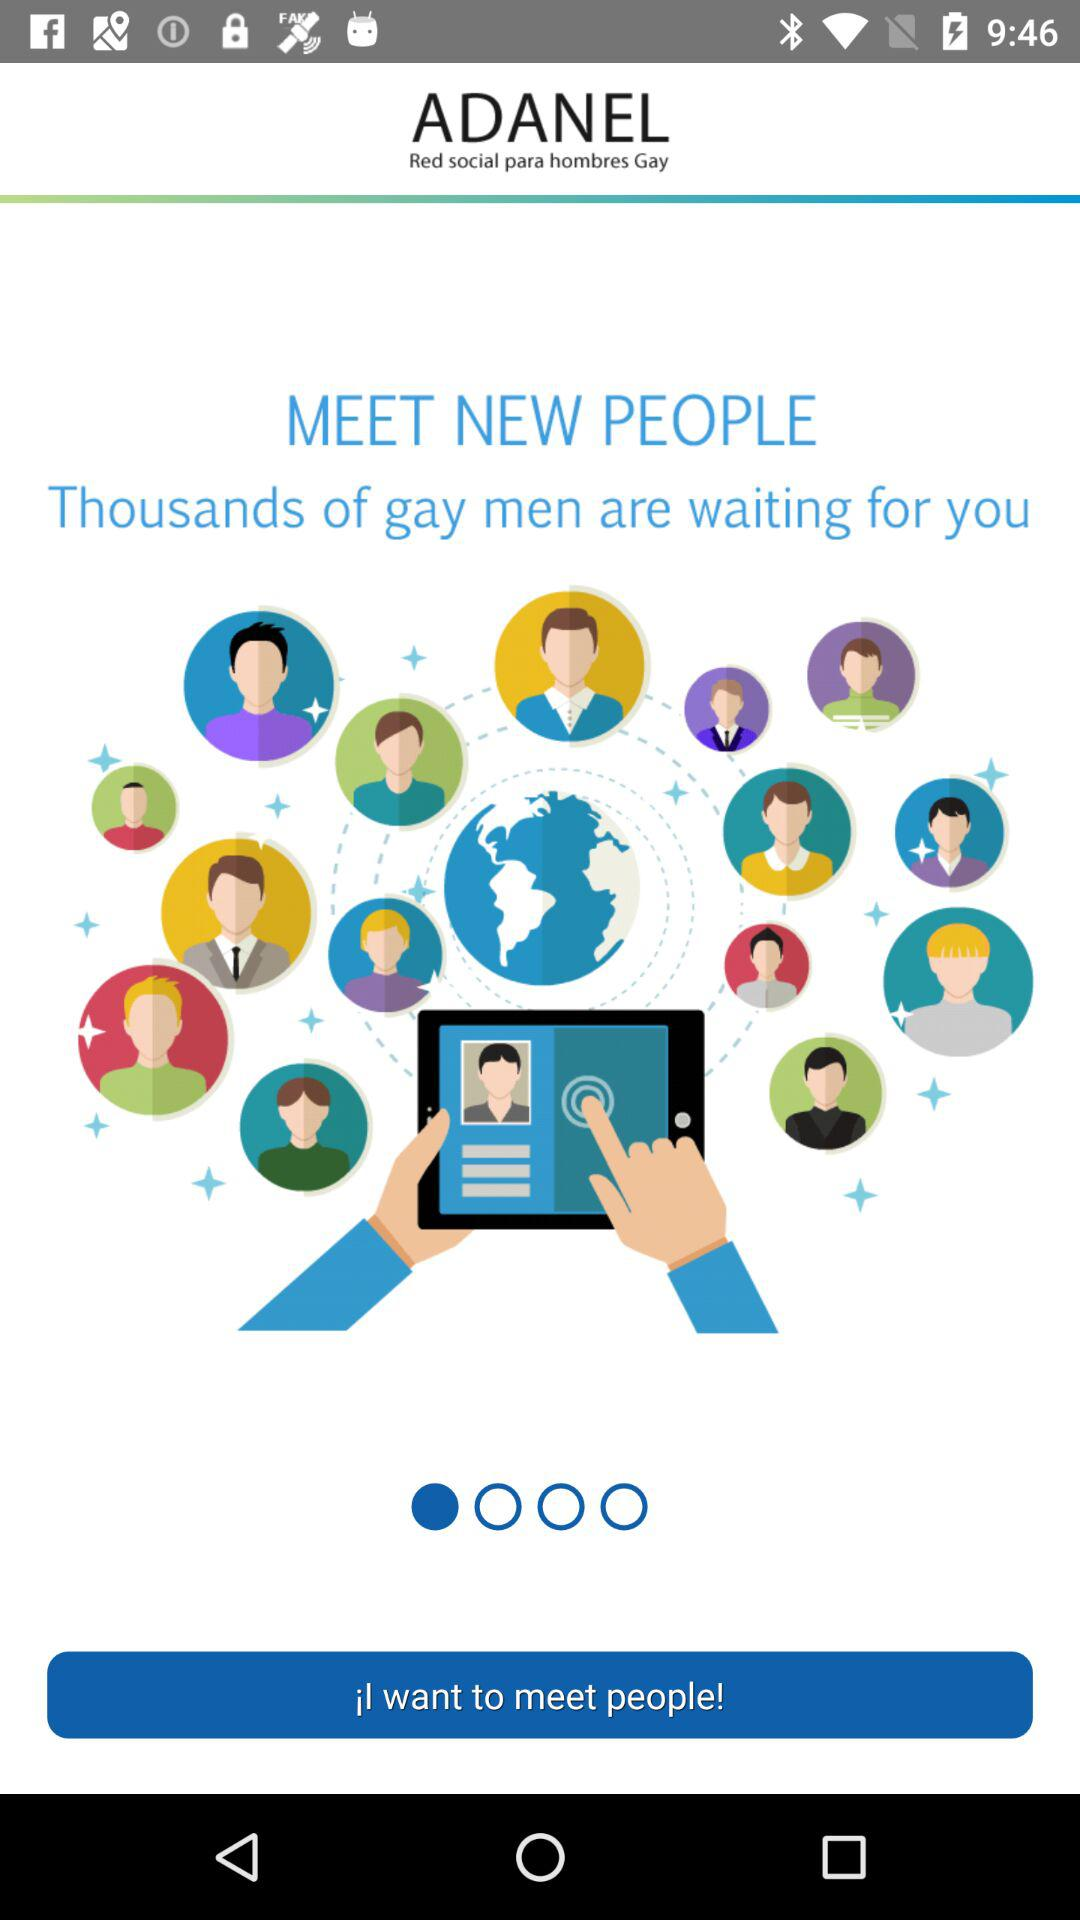What is the name of the application? The name of the application is "ADANEL". 